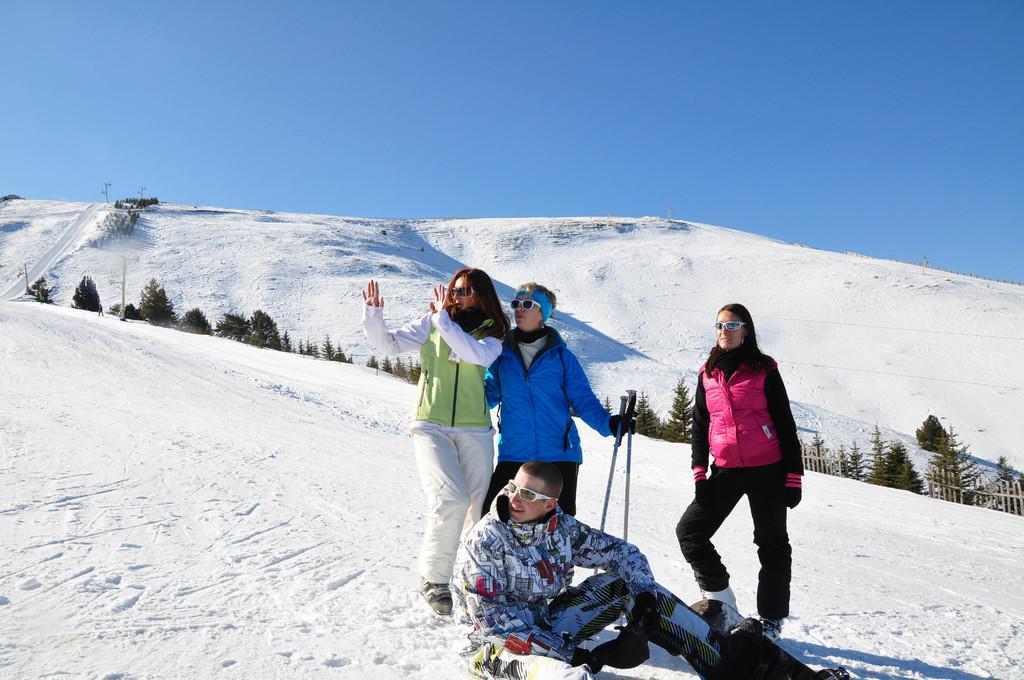Please provide a concise description of this image. There are four members in the picture. One guy is sitting on the snow. The other one is holding two skiing sticks in his hand. There is a lot of snow here. In the background, there are some trees, a snow covered mountain and a sky here. 